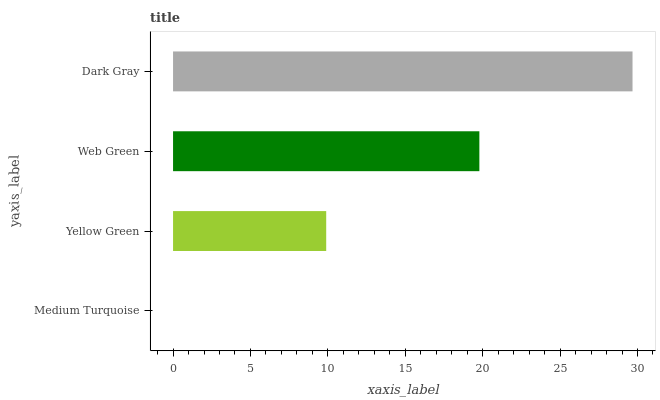Is Medium Turquoise the minimum?
Answer yes or no. Yes. Is Dark Gray the maximum?
Answer yes or no. Yes. Is Yellow Green the minimum?
Answer yes or no. No. Is Yellow Green the maximum?
Answer yes or no. No. Is Yellow Green greater than Medium Turquoise?
Answer yes or no. Yes. Is Medium Turquoise less than Yellow Green?
Answer yes or no. Yes. Is Medium Turquoise greater than Yellow Green?
Answer yes or no. No. Is Yellow Green less than Medium Turquoise?
Answer yes or no. No. Is Web Green the high median?
Answer yes or no. Yes. Is Yellow Green the low median?
Answer yes or no. Yes. Is Dark Gray the high median?
Answer yes or no. No. Is Web Green the low median?
Answer yes or no. No. 